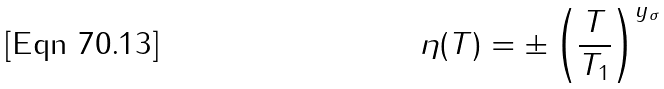Convert formula to latex. <formula><loc_0><loc_0><loc_500><loc_500>\eta ( T ) = \pm \left ( \frac { T } { T _ { 1 } } \right ) ^ { y _ { \sigma } }</formula> 